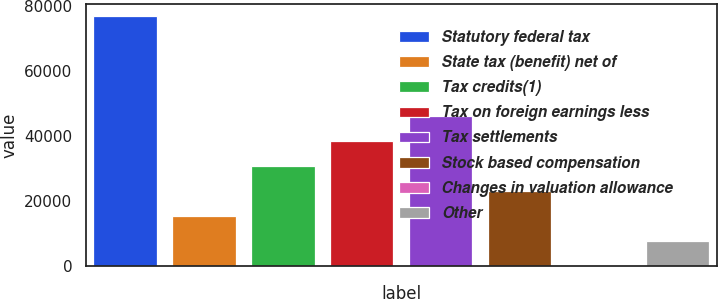Convert chart. <chart><loc_0><loc_0><loc_500><loc_500><bar_chart><fcel>Statutory federal tax<fcel>State tax (benefit) net of<fcel>Tax credits(1)<fcel>Tax on foreign earnings less<fcel>Tax settlements<fcel>Stock based compensation<fcel>Changes in valuation allowance<fcel>Other<nl><fcel>76689<fcel>15377<fcel>30705<fcel>38369<fcel>46033<fcel>23041<fcel>49<fcel>7713<nl></chart> 